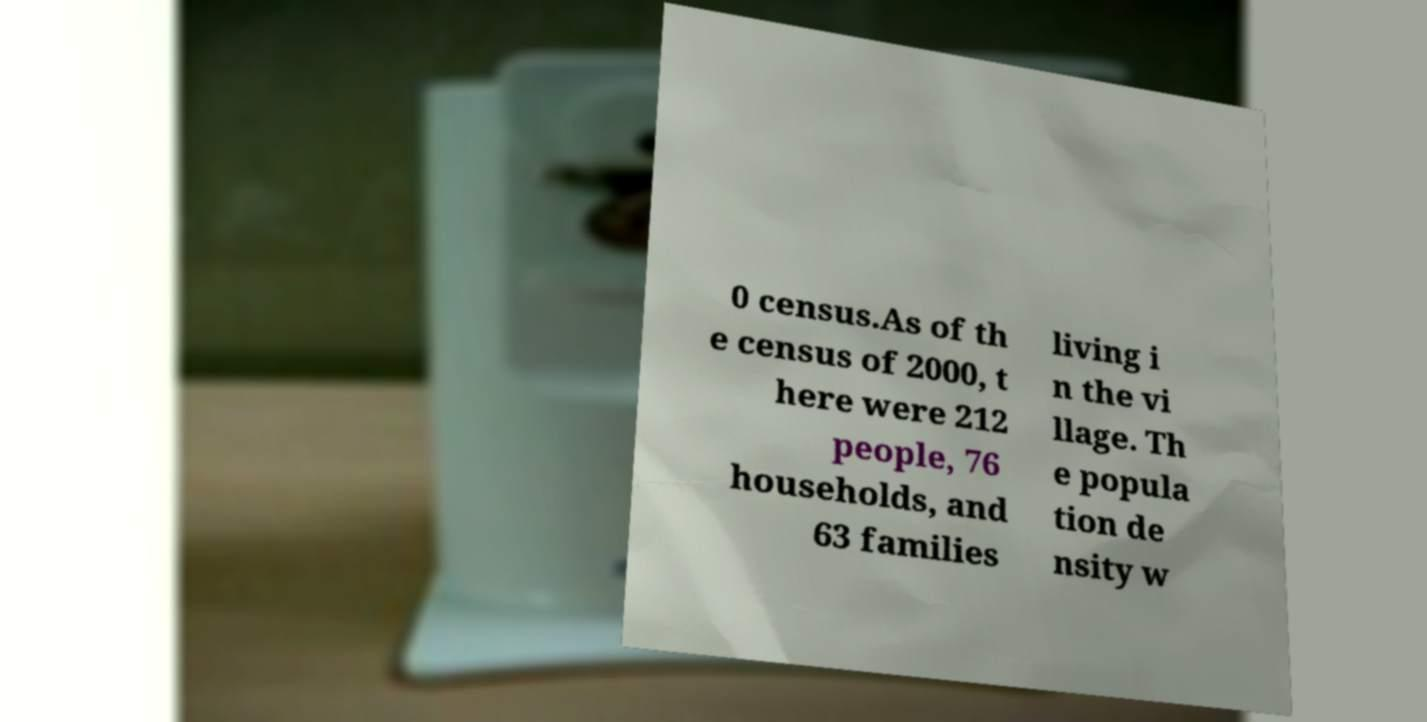For documentation purposes, I need the text within this image transcribed. Could you provide that? 0 census.As of th e census of 2000, t here were 212 people, 76 households, and 63 families living i n the vi llage. Th e popula tion de nsity w 